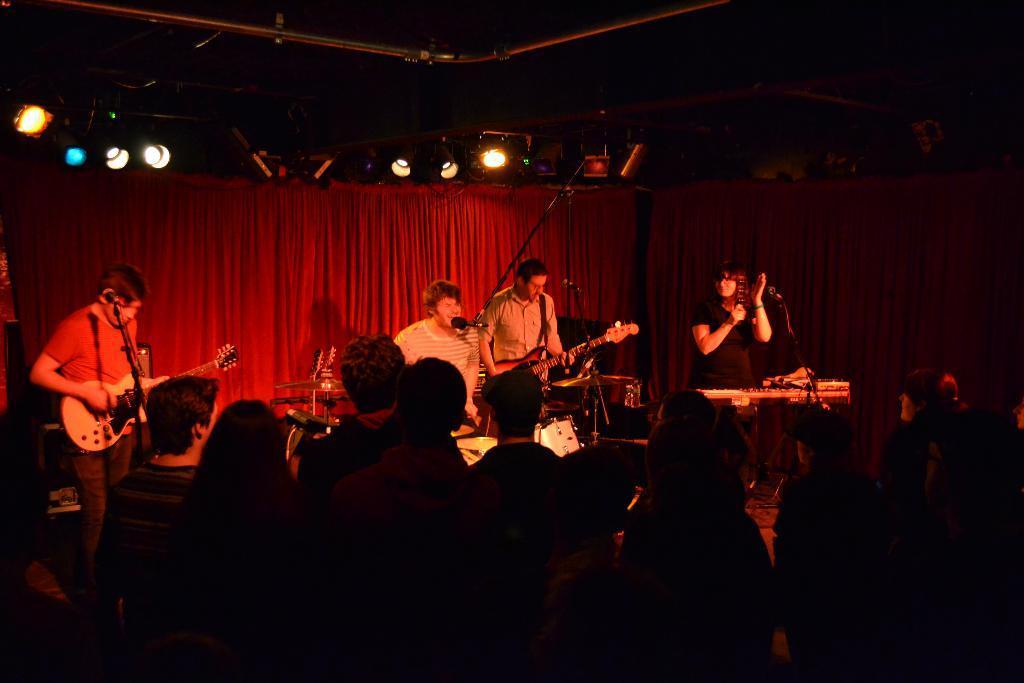Please provide a concise description of this image. In this image there are group of people, four people standing on the stage and audience are standing opposite to them. Two persons are playing guitar and one person is singing. At the back there is a red curtain and at the top there are lights. 